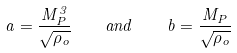<formula> <loc_0><loc_0><loc_500><loc_500>a = \frac { M _ { P } ^ { 3 } } { \sqrt { \rho _ { o } } } \quad a n d \quad b = \frac { M _ { P } } { \sqrt { \rho _ { o } } }</formula> 